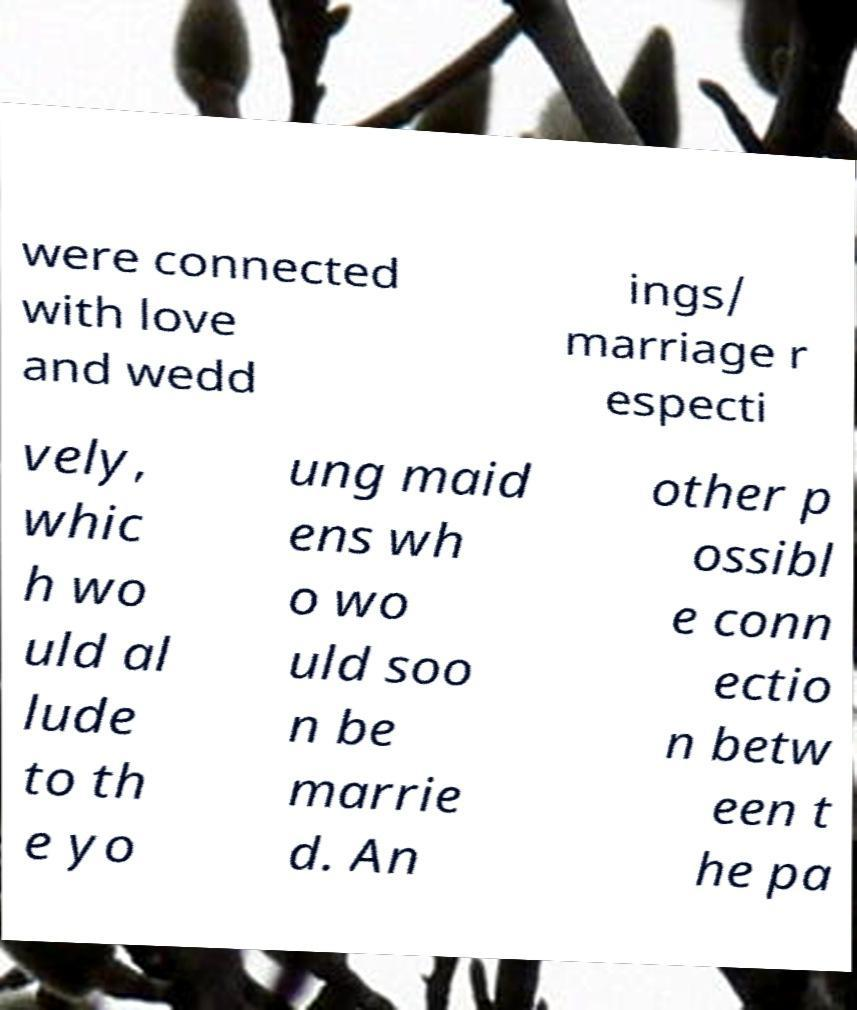Could you assist in decoding the text presented in this image and type it out clearly? were connected with love and wedd ings/ marriage r especti vely, whic h wo uld al lude to th e yo ung maid ens wh o wo uld soo n be marrie d. An other p ossibl e conn ectio n betw een t he pa 